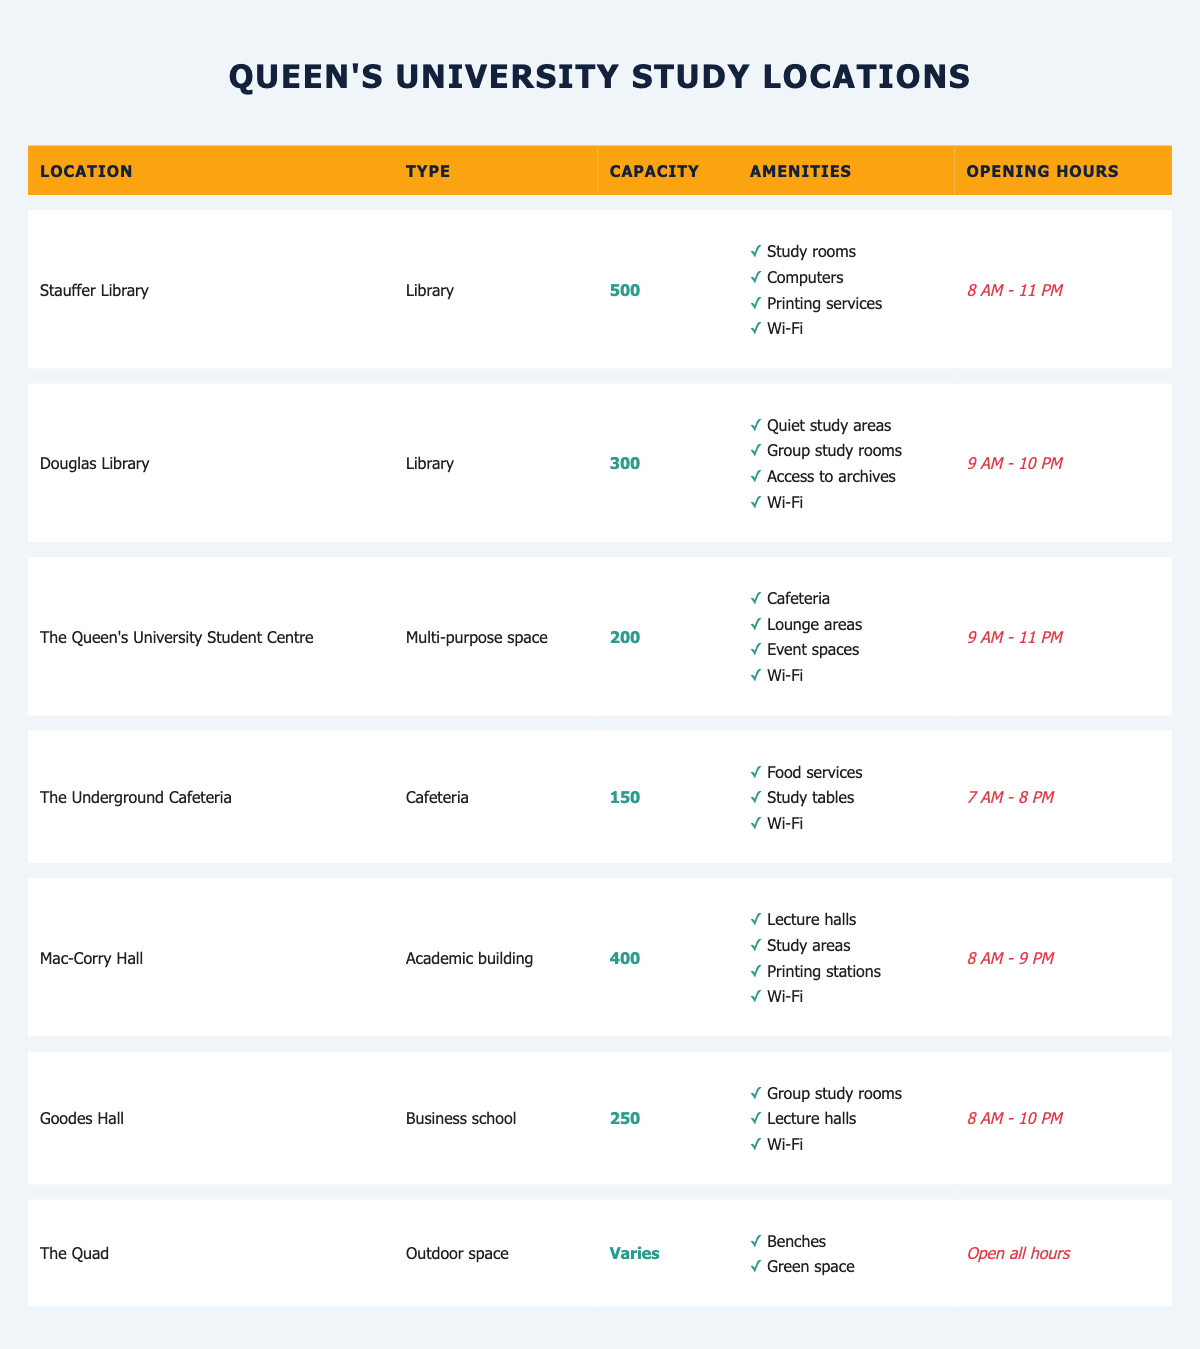What is the capacity of Stauffer Library? The Stauffer Library is listed in the table with a specified capacity of 500. You can find this value directly in the 'Capacity' column for Stauffer Library.
Answer: 500 Which location has the longest opening hours? To determine which location has the longest opening hours, we need to compare the opening hours of all the locations. Stauffer Library is open from 8 AM to 11 PM, and the Queen’s University Student Centre is also open until 11 PM, but it opens later at 9 AM. The other locations have shorter hours, so Stauffer Library and the Queen’s University Student Centre have the longest hours.
Answer: Stauffer Library and The Queen's University Student Centre Does The Underground Cafeteria have Wi-Fi? The amenities listed for The Underground Cafeteria include "Food services," "Study tables," and "Wi-Fi." Since Wi-Fi is explicitly mentioned, the answer is yes.
Answer: Yes How many total study spaces are available across all locations? To find the total number of study spaces, we need to sum up the capacities of all the study locations. We add Stauffer Library (500), Douglas Library (300), The Queen's University Student Centre (200), The Underground Cafeteria (150), Mac-Corry Hall (400), Goodes Hall (250), and since The Quad’s capacity varies, we will not include it. Adding these up gives 500 + 300 + 200 + 150 + 400 + 250 = 1800.
Answer: 1800 Which location has the fewest available amenities? To find the location with the fewest amenities, we need to count the amenities listed for each location. The Underground Cafeteria has three amenities (Food services, Study tables, and Wi-Fi), while others have four. Goodes Hall also has three but with four items listed. Hence, The Underground Cafeteria is the location with the fewest amenities.
Answer: The Underground Cafeteria 